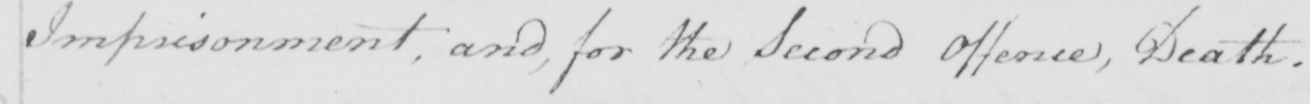Please transcribe the handwritten text in this image. Imprisonment , and , for the second Offence , Death . 